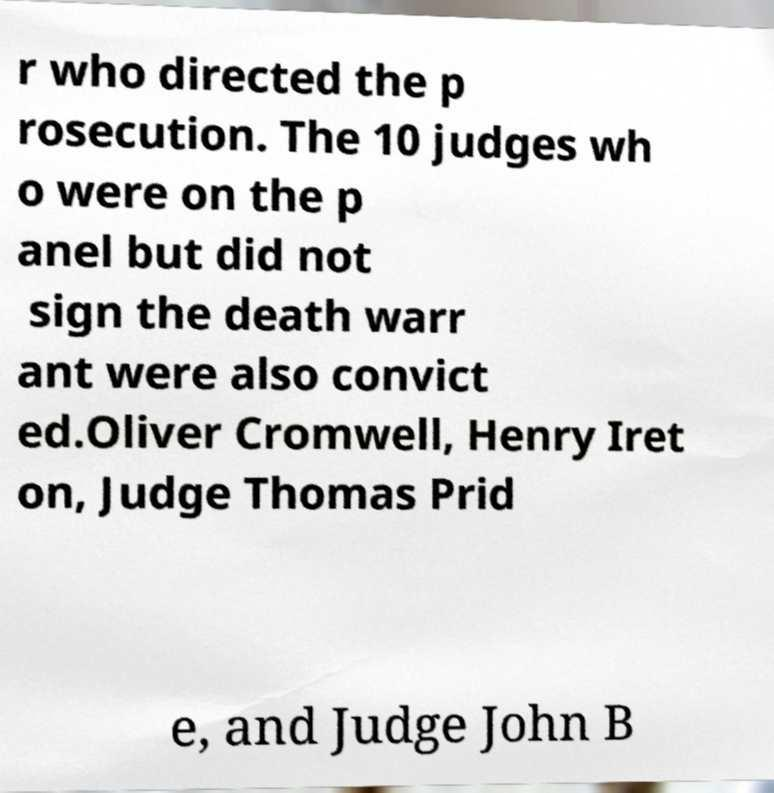Can you accurately transcribe the text from the provided image for me? r who directed the p rosecution. The 10 judges wh o were on the p anel but did not sign the death warr ant were also convict ed.Oliver Cromwell, Henry Iret on, Judge Thomas Prid e, and Judge John B 